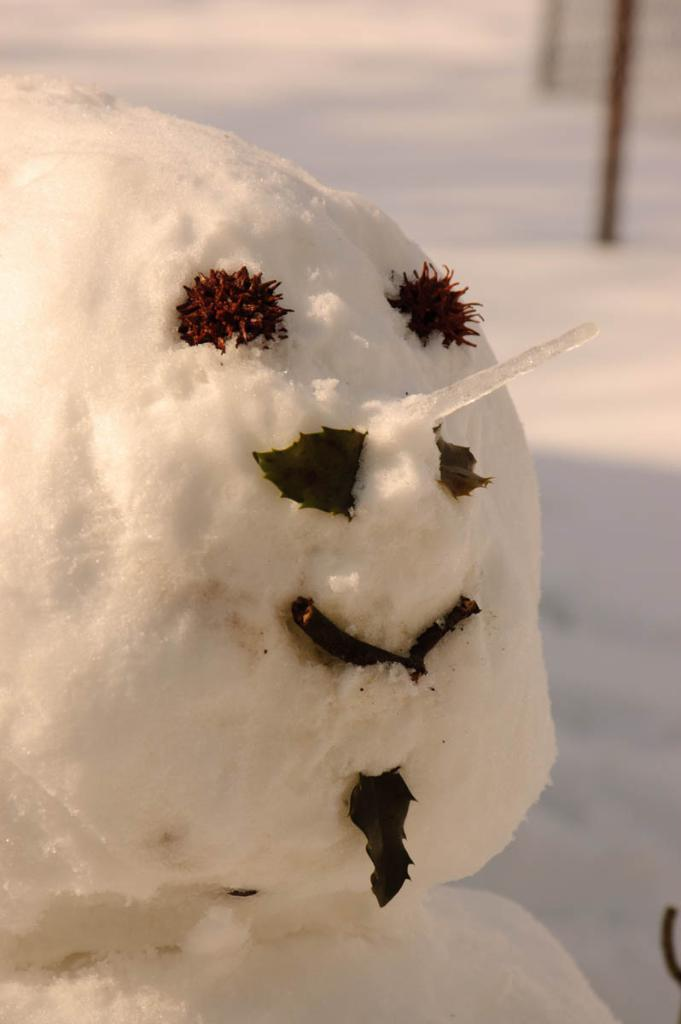What is the main subject in the image? There is a snowman in the image. What can be observed about the ground in the image? There is snow on the ground in the image. What type of pencil can be seen in the image? There is no pencil present in the image. Can you tell me how many airplanes are visible in the image? There are no airplanes visible in the image. Is there any indication of tax being collected in the image? There is no indication of tax being collected in the image. 